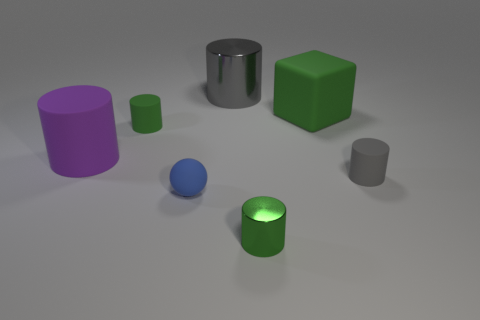What number of things are either big green objects or green objects that are behind the large purple matte thing?
Make the answer very short. 2. There is a small thing that is the same color as the big shiny cylinder; what material is it?
Offer a very short reply. Rubber. Is the size of the green object left of the blue sphere the same as the gray rubber thing?
Provide a short and direct response. Yes. There is a gray thing in front of the green object that is left of the small shiny cylinder; what number of small cylinders are behind it?
Your answer should be very brief. 1. How many gray objects are small shiny cylinders or small matte cylinders?
Your answer should be compact. 1. The large cube that is made of the same material as the large purple cylinder is what color?
Your answer should be very brief. Green. Is there any other thing that is the same size as the purple rubber cylinder?
Your answer should be compact. Yes. How many small things are either cubes or purple rubber things?
Your answer should be very brief. 0. Is the number of small gray matte cylinders less than the number of small blue cylinders?
Make the answer very short. No. There is a large metal thing that is the same shape as the big purple rubber thing; what color is it?
Give a very brief answer. Gray. 